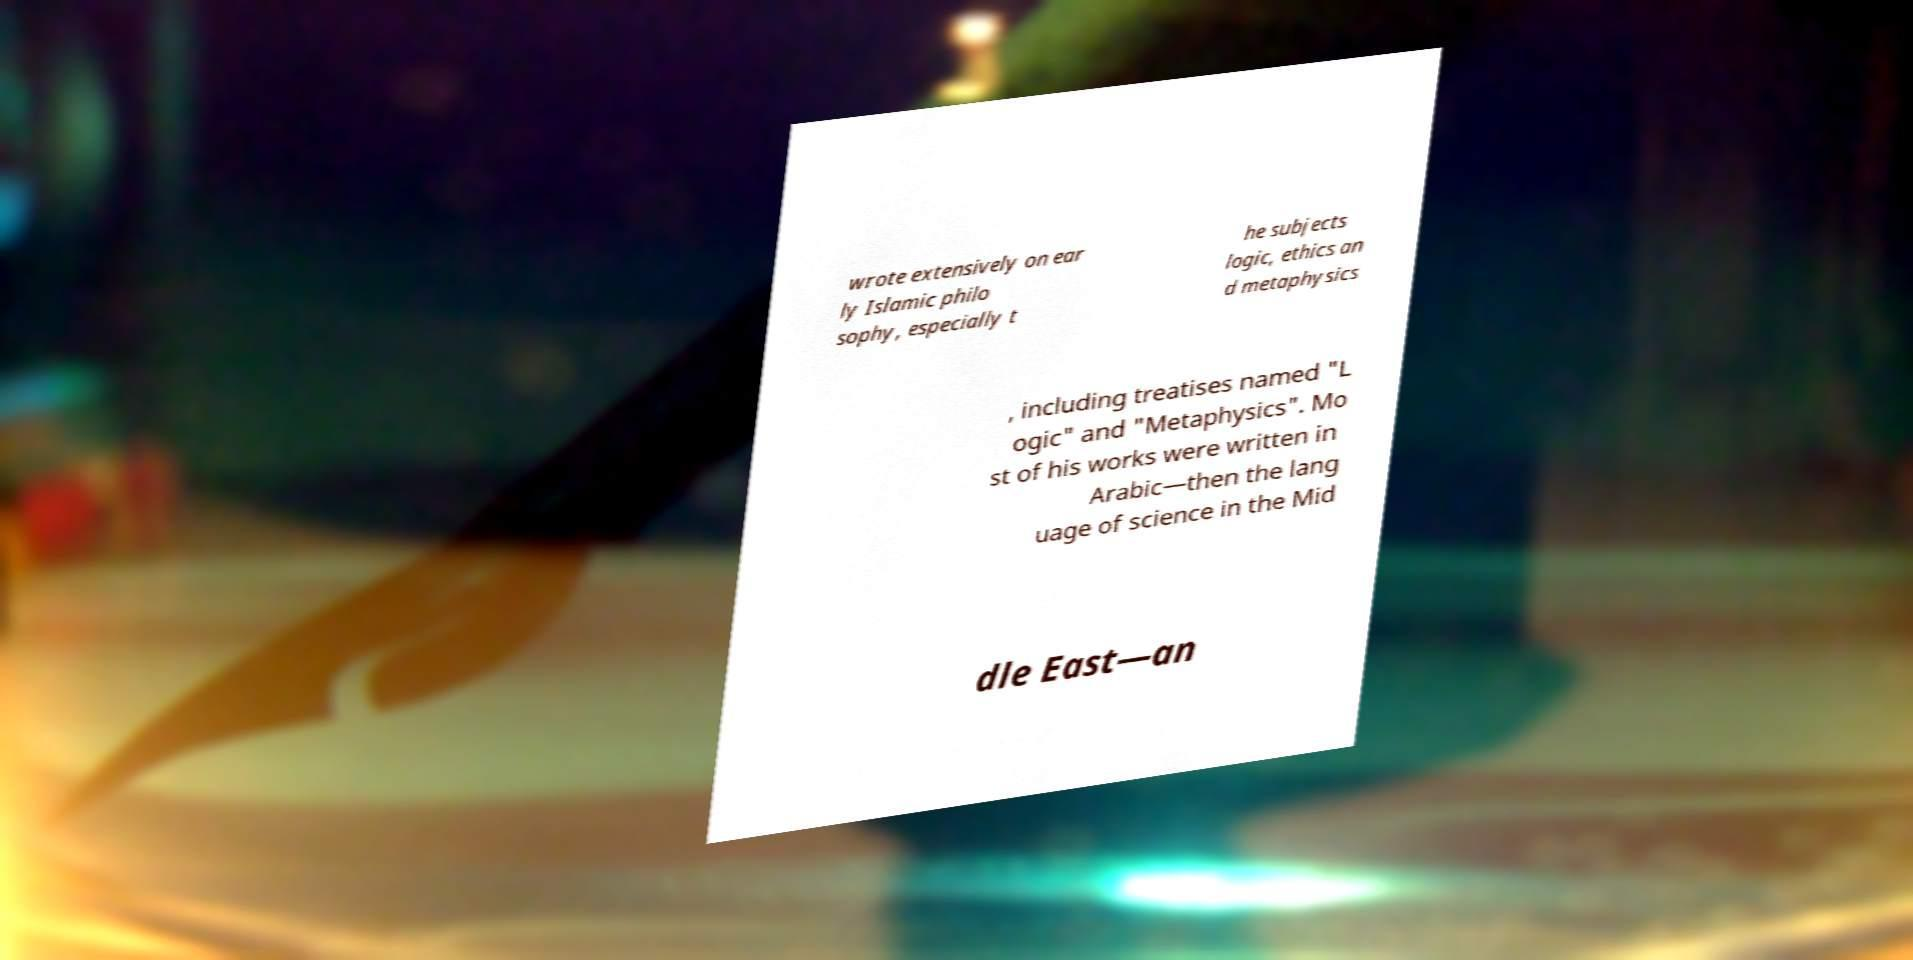Please read and relay the text visible in this image. What does it say? wrote extensively on ear ly Islamic philo sophy, especially t he subjects logic, ethics an d metaphysics , including treatises named "L ogic" and "Metaphysics". Mo st of his works were written in Arabic—then the lang uage of science in the Mid dle East—an 